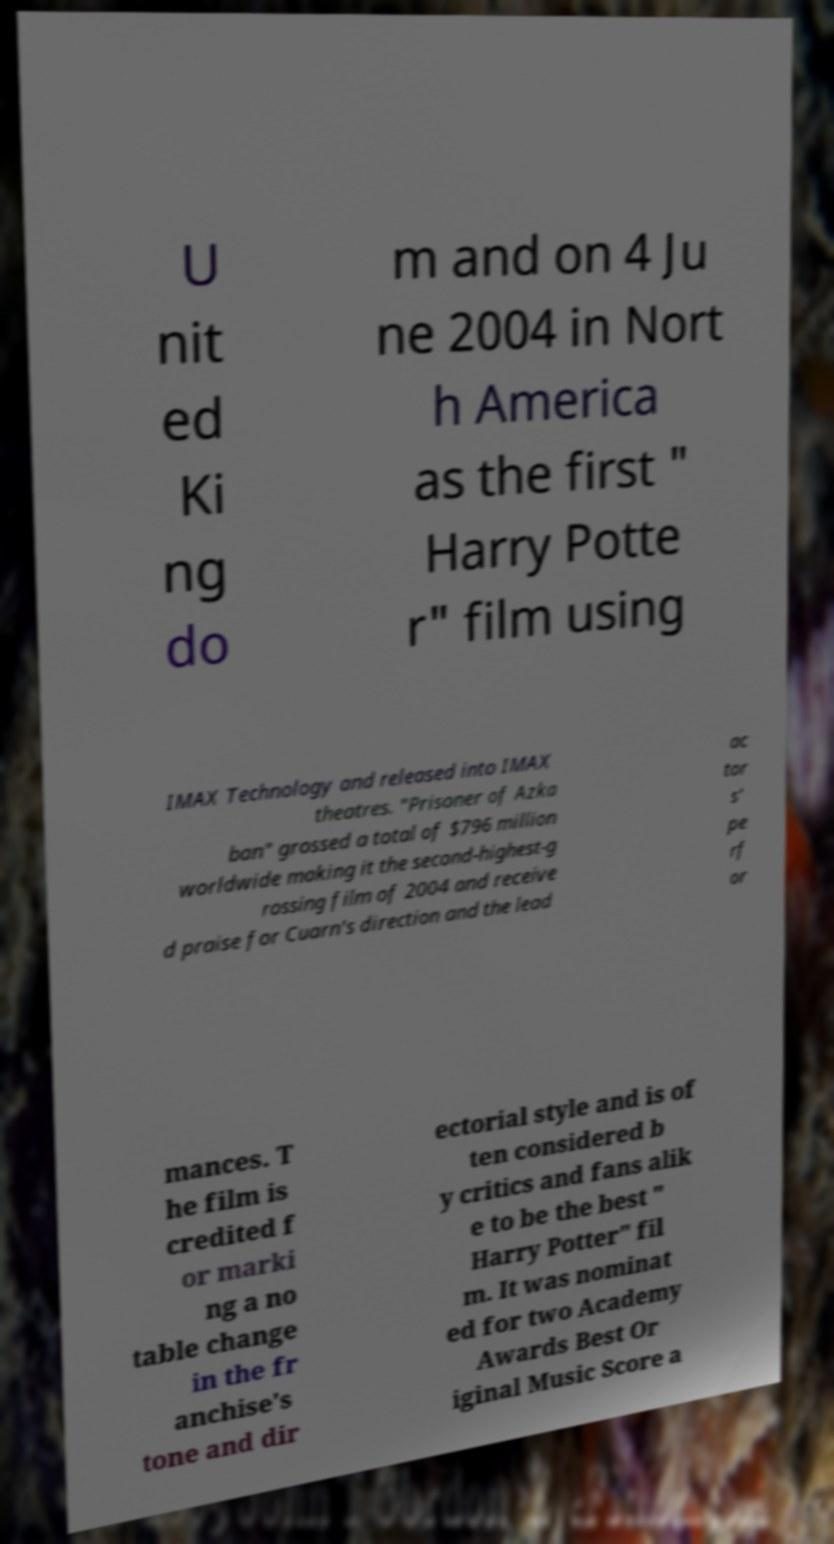What messages or text are displayed in this image? I need them in a readable, typed format. U nit ed Ki ng do m and on 4 Ju ne 2004 in Nort h America as the first " Harry Potte r" film using IMAX Technology and released into IMAX theatres. "Prisoner of Azka ban" grossed a total of $796 million worldwide making it the second-highest-g rossing film of 2004 and receive d praise for Cuarn's direction and the lead ac tor s' pe rf or mances. T he film is credited f or marki ng a no table change in the fr anchise's tone and dir ectorial style and is of ten considered b y critics and fans alik e to be the best " Harry Potter" fil m. It was nominat ed for two Academy Awards Best Or iginal Music Score a 